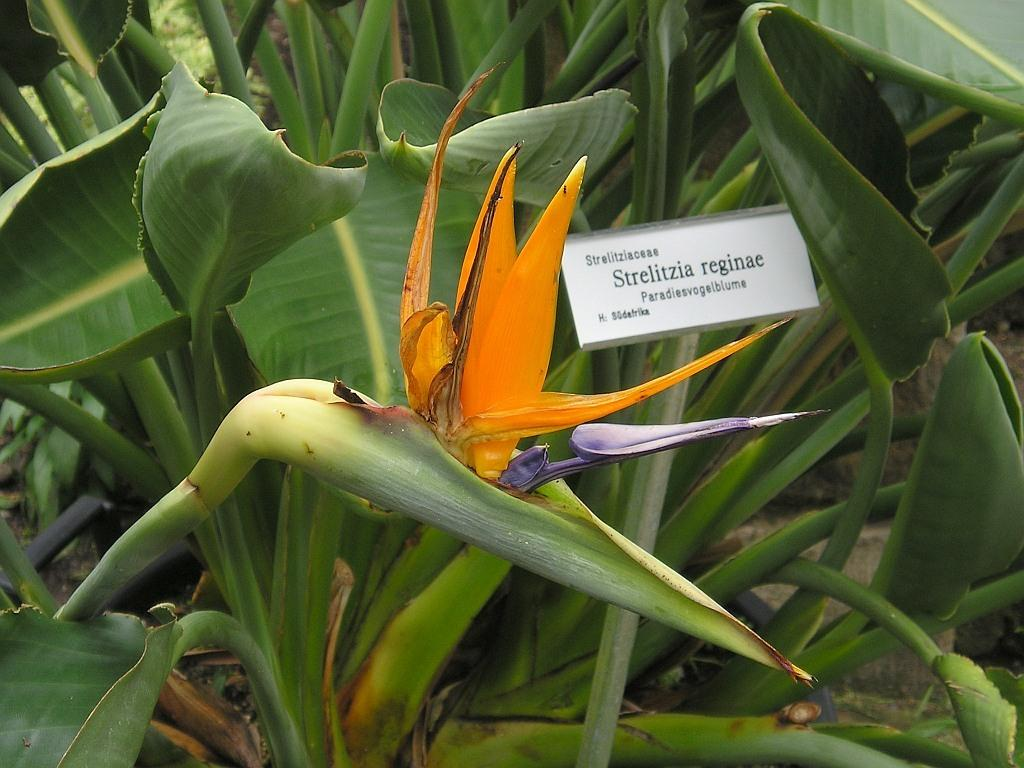What type of living organisms can be seen in the image? Plants can be seen in the image. Can you describe the main feature of the image? There is a flower in the center of the image. What type of snake can be seen slithering through the flower in the image? There is no snake present in the image; it only features plants and a flower. 